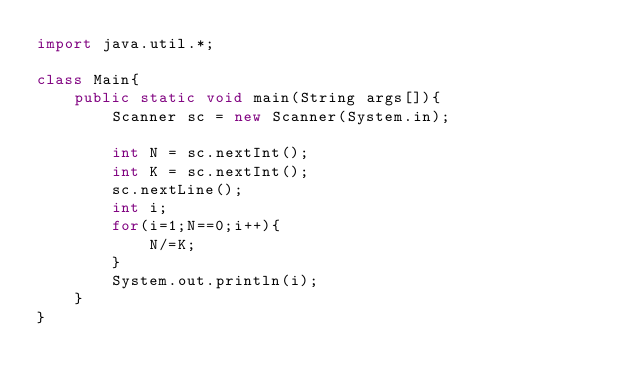Convert code to text. <code><loc_0><loc_0><loc_500><loc_500><_Java_>import java.util.*;

class Main{
    public static void main(String args[]){
        Scanner sc = new Scanner(System.in);

        int N = sc.nextInt();
        int K = sc.nextInt();
        sc.nextLine();
        int i;
        for(i=1;N==0;i++){
            N/=K;
        }
        System.out.println(i);
    }
}</code> 